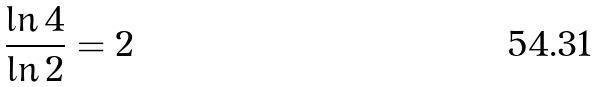<formula> <loc_0><loc_0><loc_500><loc_500>\frac { \ln 4 } { \ln 2 } = 2</formula> 